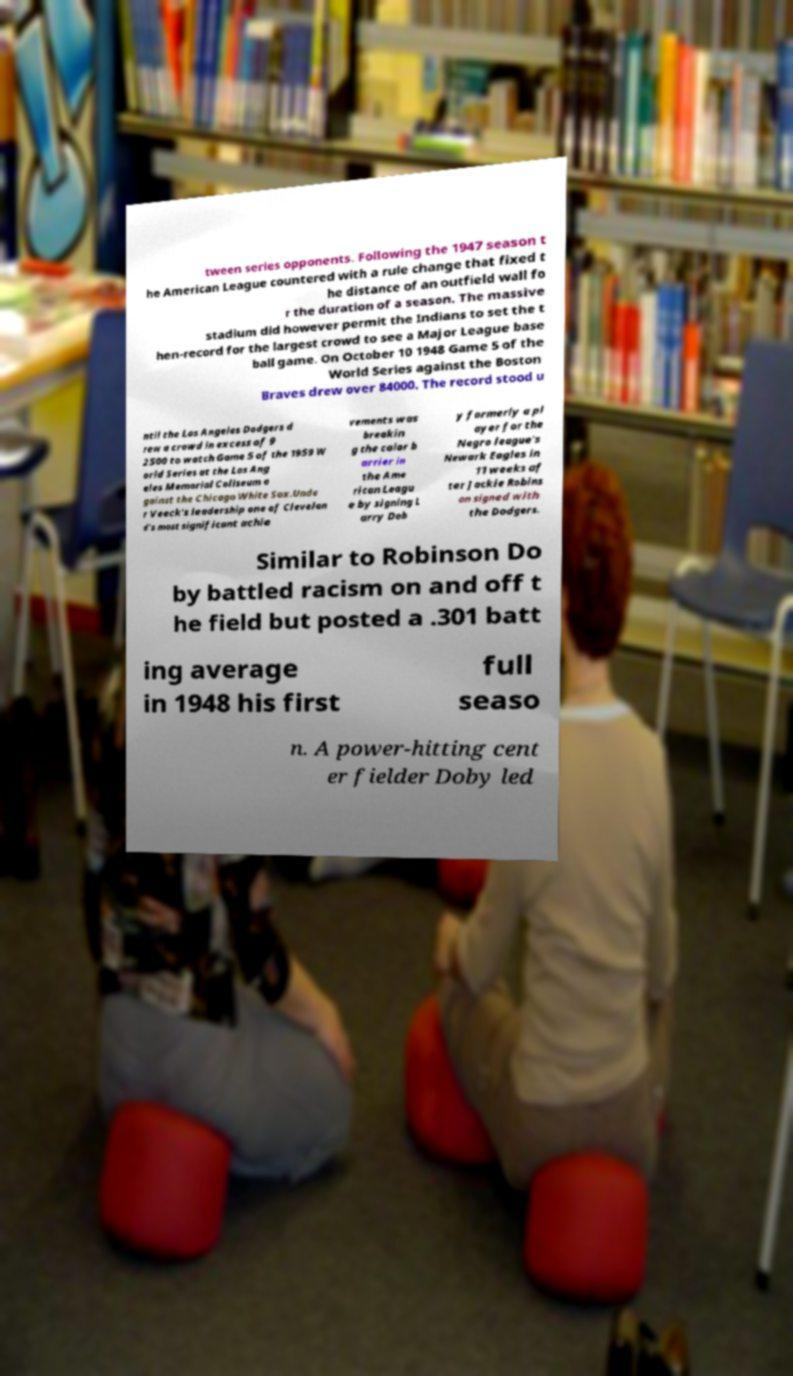Could you assist in decoding the text presented in this image and type it out clearly? tween series opponents. Following the 1947 season t he American League countered with a rule change that fixed t he distance of an outfield wall fo r the duration of a season. The massive stadium did however permit the Indians to set the t hen-record for the largest crowd to see a Major League base ball game. On October 10 1948 Game 5 of the World Series against the Boston Braves drew over 84000. The record stood u ntil the Los Angeles Dodgers d rew a crowd in excess of 9 2500 to watch Game 5 of the 1959 W orld Series at the Los Ang eles Memorial Coliseum a gainst the Chicago White Sox.Unde r Veeck's leadership one of Clevelan d's most significant achie vements was breakin g the color b arrier in the Ame rican Leagu e by signing L arry Dob y formerly a pl ayer for the Negro league's Newark Eagles in 11 weeks af ter Jackie Robins on signed with the Dodgers. Similar to Robinson Do by battled racism on and off t he field but posted a .301 batt ing average in 1948 his first full seaso n. A power-hitting cent er fielder Doby led 